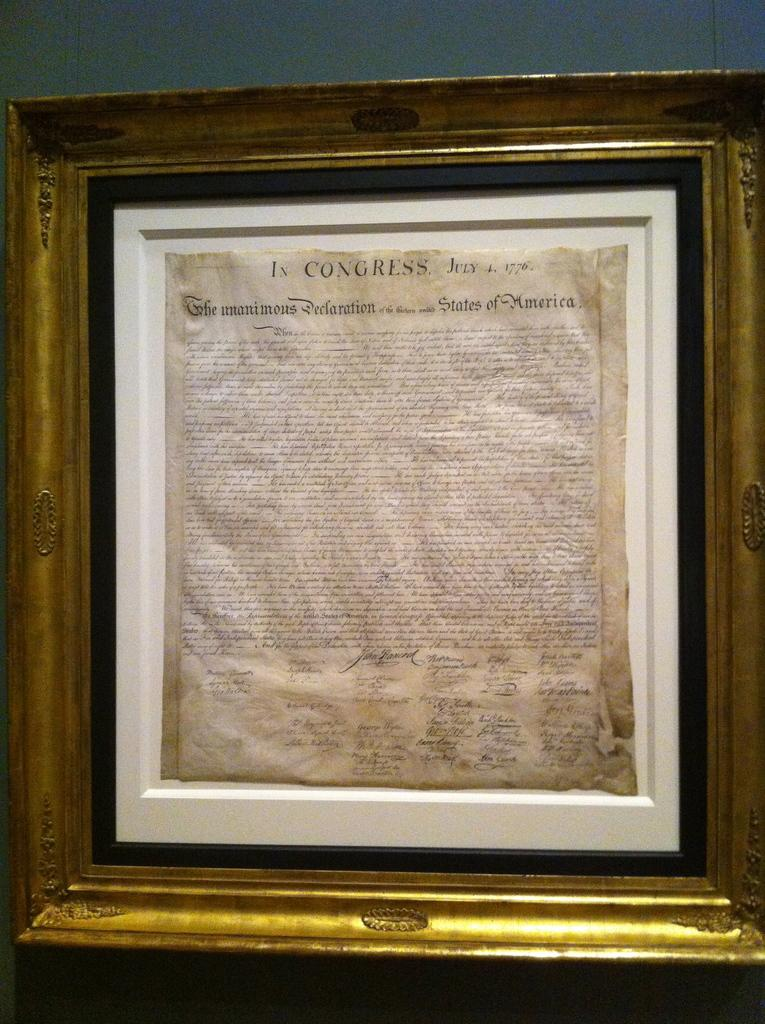<image>
Offer a succinct explanation of the picture presented. Letter framed on a wall that starts off with the word Congress. 